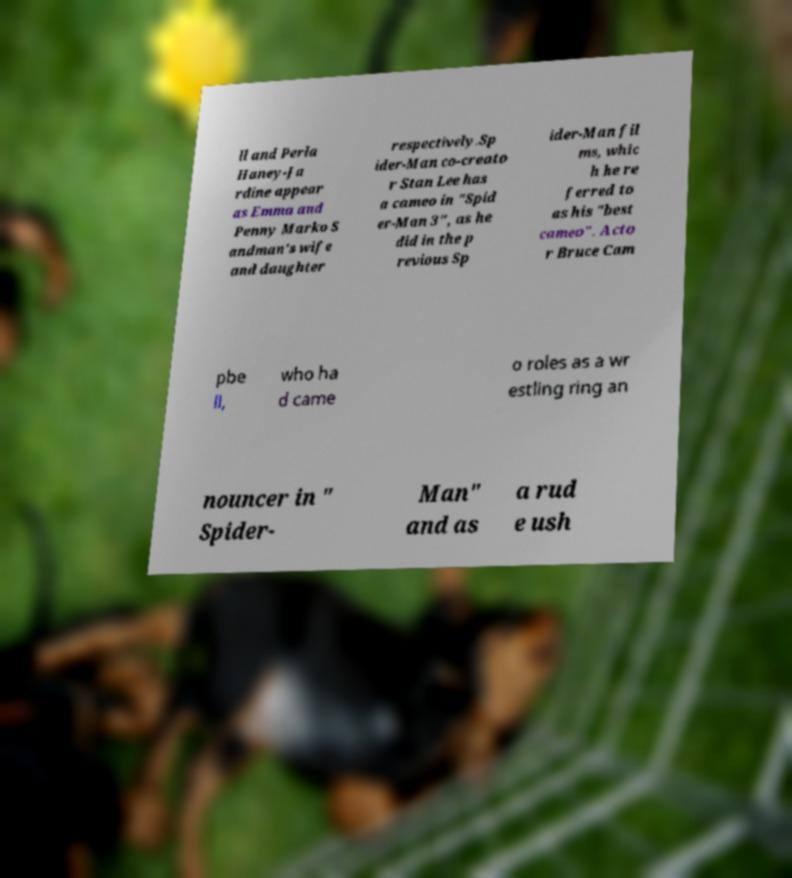Could you extract and type out the text from this image? ll and Perla Haney-Ja rdine appear as Emma and Penny Marko S andman's wife and daughter respectively.Sp ider-Man co-creato r Stan Lee has a cameo in "Spid er-Man 3", as he did in the p revious Sp ider-Man fil ms, whic h he re ferred to as his "best cameo". Acto r Bruce Cam pbe ll, who ha d came o roles as a wr estling ring an nouncer in " Spider- Man" and as a rud e ush 